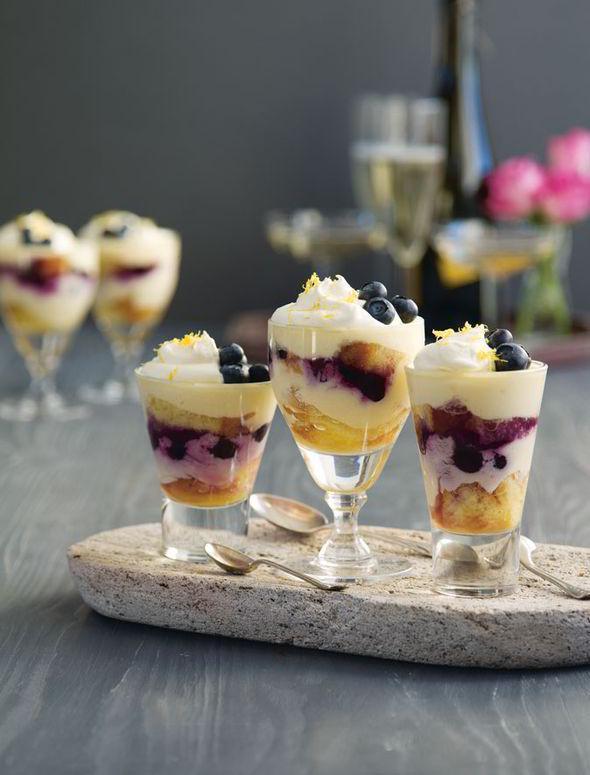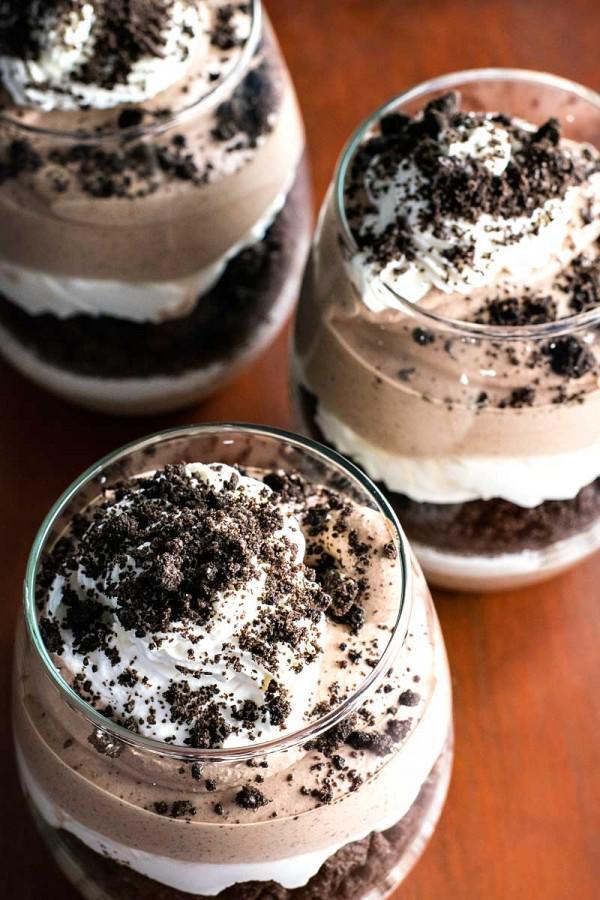The first image is the image on the left, the second image is the image on the right. For the images shown, is this caption "# glasses are filed with cream and fruit." true? Answer yes or no. Yes. The first image is the image on the left, the second image is the image on the right. For the images shown, is this caption "In both pictures on the right side, there are three glasses the contain layers of chocolate and whipped cream topped with cookie crumbles." true? Answer yes or no. Yes. 